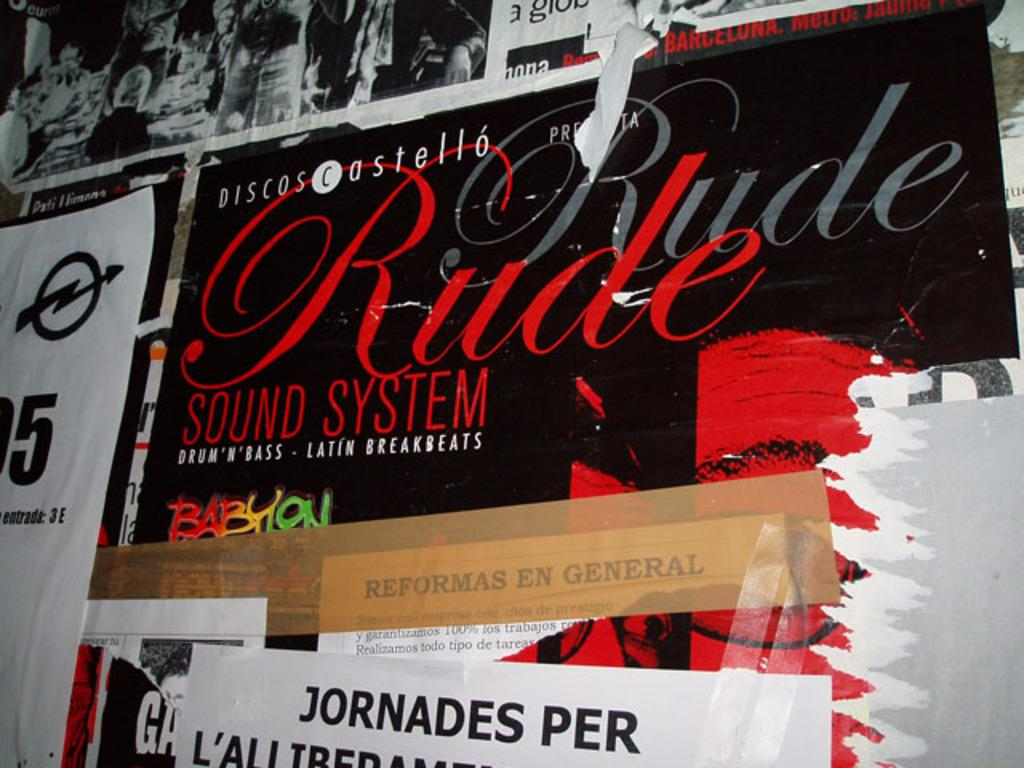What is hanging on the wall in the image? There are posters and banners on the wall in the image. Can you describe the posters and banners? Unfortunately, the details of the posters and banners cannot be determined from the provided facts. How many turkeys are visible on the plantation in the image? There is no mention of a plantation or turkeys in the provided facts, so it cannot be determined from the image. 